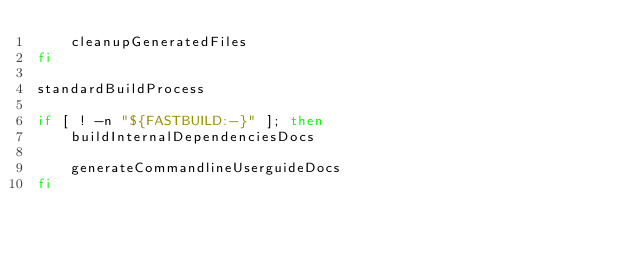Convert code to text. <code><loc_0><loc_0><loc_500><loc_500><_Bash_>	cleanupGeneratedFiles
fi

standardBuildProcess

if [ ! -n "${FASTBUILD:-}" ]; then
	buildInternalDependenciesDocs

	generateCommandlineUserguideDocs
fi

</code> 